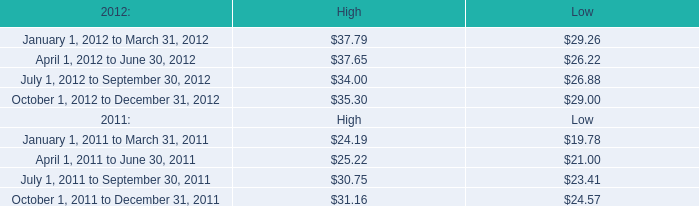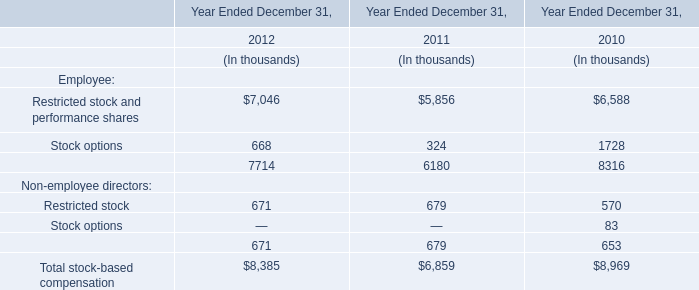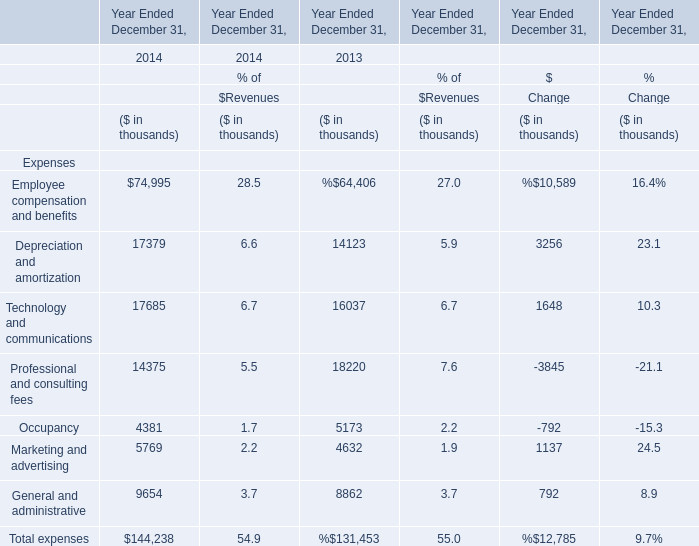In what year is Professional and consulting fees positive? 
Answer: 2013 20124. 